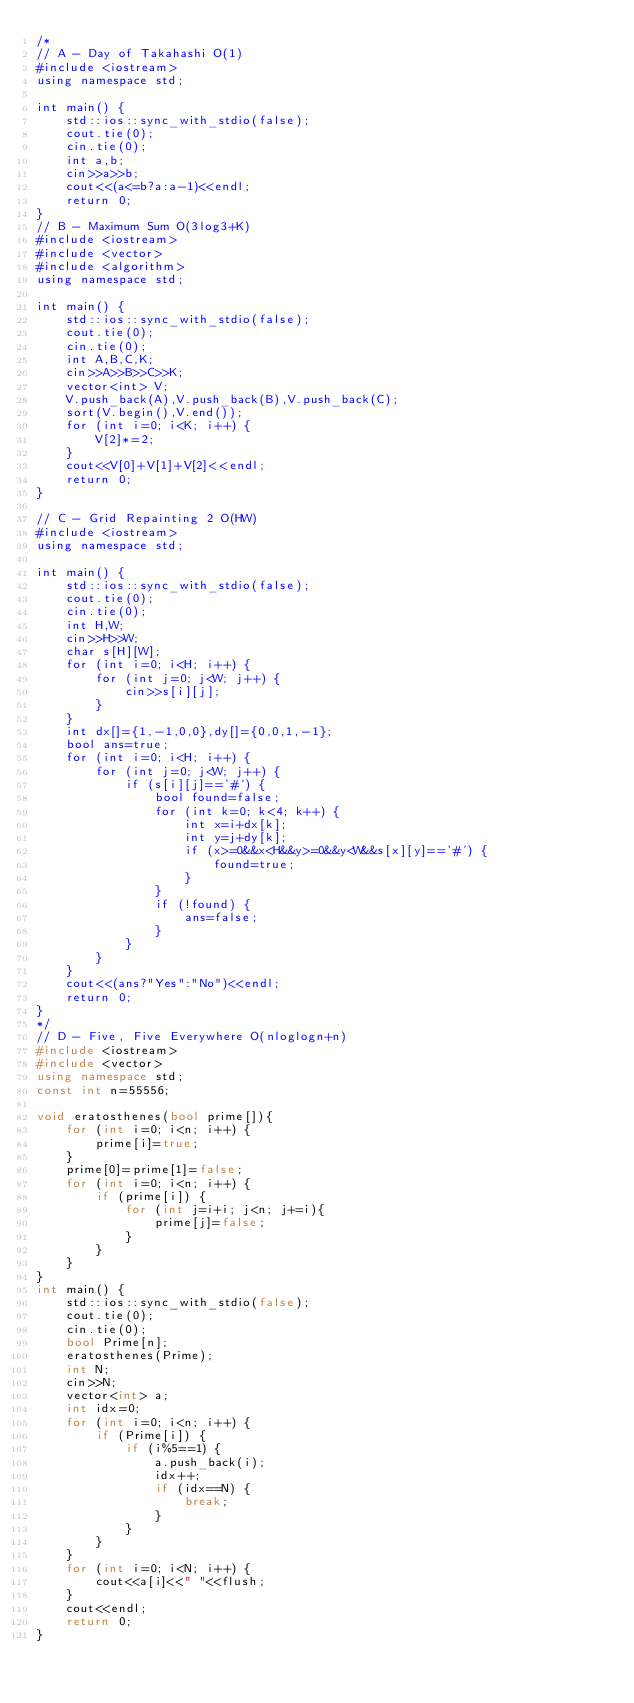<code> <loc_0><loc_0><loc_500><loc_500><_C++_>/*
// A - Day of Takahashi O(1)
#include <iostream>
using namespace std;

int main() {
    std::ios::sync_with_stdio(false);
    cout.tie(0);
    cin.tie(0);
    int a,b;
    cin>>a>>b;
    cout<<(a<=b?a:a-1)<<endl;
    return 0;
}
// B - Maximum Sum O(3log3+K)
#include <iostream>
#include <vector>
#include <algorithm>
using namespace std;

int main() {
    std::ios::sync_with_stdio(false);
    cout.tie(0);
    cin.tie(0);
    int A,B,C,K;
    cin>>A>>B>>C>>K;
    vector<int> V;
    V.push_back(A),V.push_back(B),V.push_back(C);
    sort(V.begin(),V.end());
    for (int i=0; i<K; i++) {
        V[2]*=2;
    }
    cout<<V[0]+V[1]+V[2]<<endl;
    return 0;
}

// C - Grid Repainting 2 O(HW)
#include <iostream>
using namespace std;

int main() {
    std::ios::sync_with_stdio(false);
    cout.tie(0);
    cin.tie(0);
    int H,W;
    cin>>H>>W;
    char s[H][W];
    for (int i=0; i<H; i++) {
        for (int j=0; j<W; j++) {
            cin>>s[i][j];
        }
    }
    int dx[]={1,-1,0,0},dy[]={0,0,1,-1};
    bool ans=true;
    for (int i=0; i<H; i++) {
        for (int j=0; j<W; j++) {
            if (s[i][j]=='#') {
                bool found=false;
                for (int k=0; k<4; k++) {
                    int x=i+dx[k];
                    int y=j+dy[k];
                    if (x>=0&&x<H&&y>=0&&y<W&&s[x][y]=='#') {
                        found=true;
                    }
                }
                if (!found) {
                    ans=false;
                }
            }
        }
    }
    cout<<(ans?"Yes":"No")<<endl;
    return 0;
}
*/
// D - Five, Five Everywhere O(nloglogn+n)
#include <iostream>
#include <vector>
using namespace std;
const int n=55556;

void eratosthenes(bool prime[]){
    for (int i=0; i<n; i++) {
        prime[i]=true;
    }
    prime[0]=prime[1]=false;
    for (int i=0; i<n; i++) {
        if (prime[i]) {
            for (int j=i+i; j<n; j+=i){
                prime[j]=false;
            }
        }
    }
}
int main() {
    std::ios::sync_with_stdio(false);
    cout.tie(0);
    cin.tie(0);
    bool Prime[n];
    eratosthenes(Prime);
    int N;
    cin>>N;
    vector<int> a;
    int idx=0;
    for (int i=0; i<n; i++) {
        if (Prime[i]) {
            if (i%5==1) {
                a.push_back(i);
                idx++;
                if (idx==N) {
                    break;
                }
            }
        }
    }
    for (int i=0; i<N; i++) {
        cout<<a[i]<<" "<<flush;
    }
    cout<<endl;
    return 0;
}</code> 